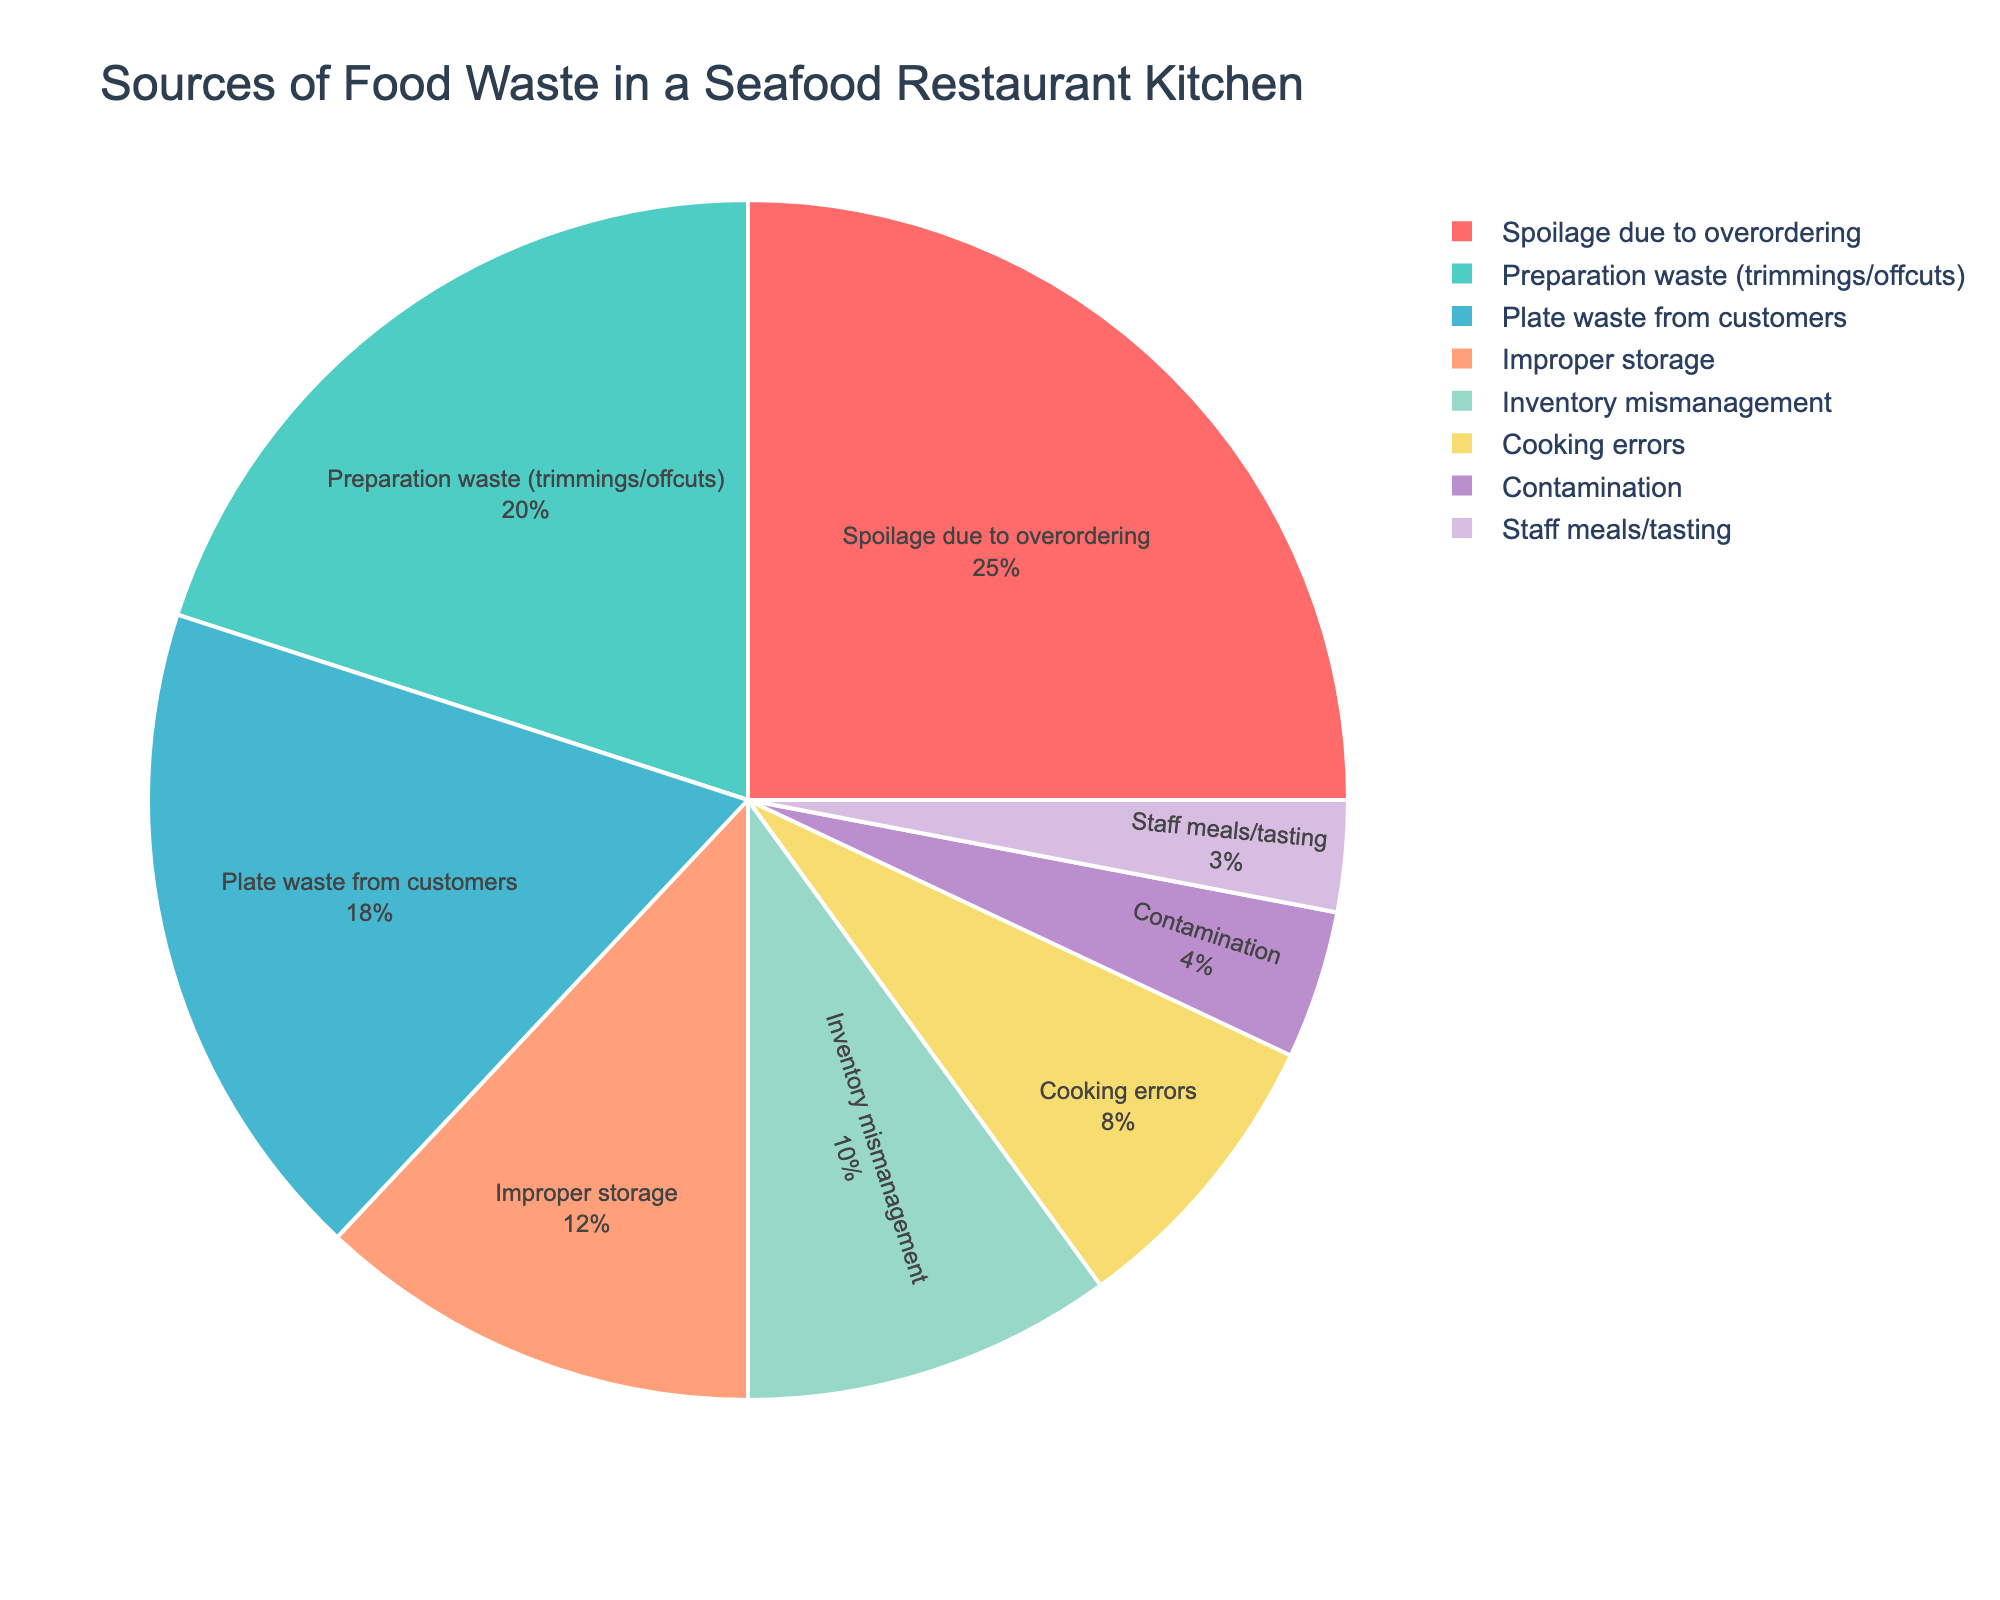What is the highest source of food waste in the seafood restaurant kitchen? Identify the category with the largest percentage in the pie chart. Spoilage due to overordering has the highest percentage at 25%.
Answer: Spoilage due to overordering What is the combined percentage of waste due to spoilage and preparation waste? Add the percentages of Spoilage due to overordering (25%) and Preparation waste (20%). 25% + 20% = 45%.
Answer: 45% Which source of food waste contributes the least? Identify the category with the smallest percentage in the pie chart. Staff meals/tasting has the smallest percentage at 3%.
Answer: Staff meals/tasting How much higher is the percentage of spoilage compared to cooking errors? Subtract Cooking errors (8%) from Spoilage due to overordering (25%). 25% - 8% = 17%.
Answer: 17% Which are the top three sources of food waste based on percentage? Identify the three categories with the highest percentages in the pie chart. They are Spoilage due to overordering (25%), Preparation waste (20%), and Plate waste from customers (18%).
Answer: Spoilage due to overordering, Preparation waste, Plate waste from customers What percentage of food waste is due to improper storage and inventory mismanagement combined? Add the percentages of Improper storage (12%) and Inventory mismanagement (10%). 12% + 10% = 22%.
Answer: 22% Compare the percentage of food waste due to improper storage and contamination. Improper storage is 12%, and Contamination is 4%. Improper storage is higher.
Answer: Improper storage is higher What is the average percentage of food waste for the categories Inventory mismanagement, Cooking errors, Contamination, and Staff meals/tasting? Sum the percentages (10% + 8% + 4% + 3%) and divide by the number of categories (4). (10 + 8 + 4 + 3) / 4 = 25 / 4 = 6.25%.
Answer: 6.25% Which color is associated with the largest percentage of food waste? The Spoilage due to overordering slice, which has the largest percentage (25%), is colored red.
Answer: Red 